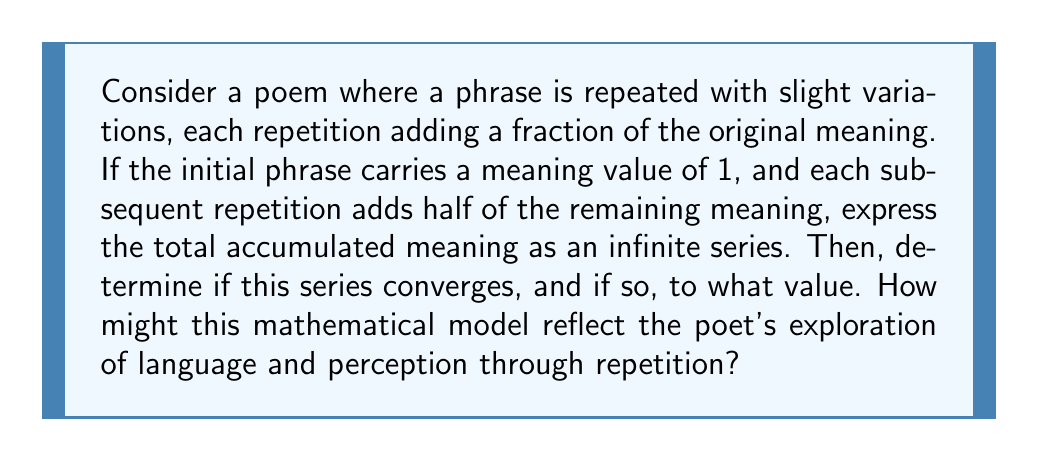Could you help me with this problem? Let's approach this problem step by step:

1) First, let's express the series mathematically:
   
   $$ S = 1 + \frac{1}{2} + \frac{1}{4} + \frac{1}{8} + ... $$

   This is a geometric series with first term $a = 1$ and common ratio $r = \frac{1}{2}$.

2) For a geometric series to converge, we need $|r| < 1$. In this case, $|\frac{1}{2}| = 0.5 < 1$, so the series converges.

3) The sum of an infinite geometric series with $|r| < 1$ is given by the formula:

   $$ S_{\infty} = \frac{a}{1-r} $$

   where $a$ is the first term and $r$ is the common ratio.

4) Substituting our values:

   $$ S_{\infty} = \frac{1}{1-\frac{1}{2}} = \frac{1}{\frac{1}{2}} = 2 $$

5) Interpreting this result:
   The total accumulated meaning converges to 2, which is twice the meaning of the original phrase. This suggests that repetition with variation can indeed amplify the original meaning, but there's a limit to how much additional meaning can be added.

6) From a poetic perspective, this mathematical model reflects how repetition can be used to build and reinforce meaning. The convergence of the series suggests that while repetition can enhance and deepen the impact of a phrase, there's a point of diminishing returns where further repetition adds less and less new meaning.

7) This aligns with the poetic concept of using repetition as a device to create emphasis, rhythm, and layered meaning. It also reflects the idea that perception of language is not simply additive, but follows a more complex pattern of assimilation and saturation.
Answer: The series converges to 2, representing a doubling of the original meaning through infinite repetitions. This mathematical model suggests that repetition in poetry can significantly enhance meaning, but with diminishing returns, reflecting the complex relationship between language, repetition, and perception. 